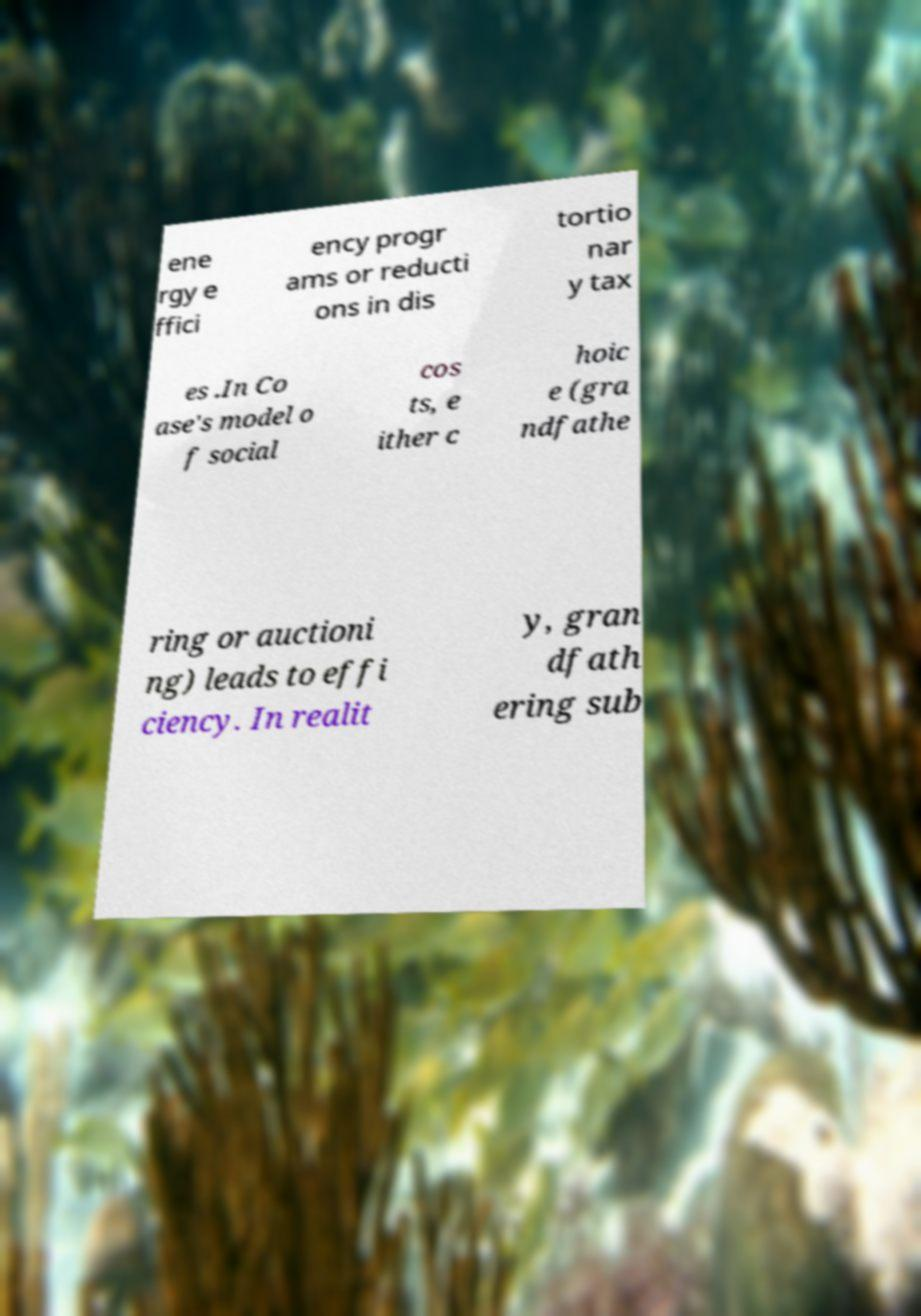There's text embedded in this image that I need extracted. Can you transcribe it verbatim? ene rgy e ffici ency progr ams or reducti ons in dis tortio nar y tax es .In Co ase's model o f social cos ts, e ither c hoic e (gra ndfathe ring or auctioni ng) leads to effi ciency. In realit y, gran dfath ering sub 